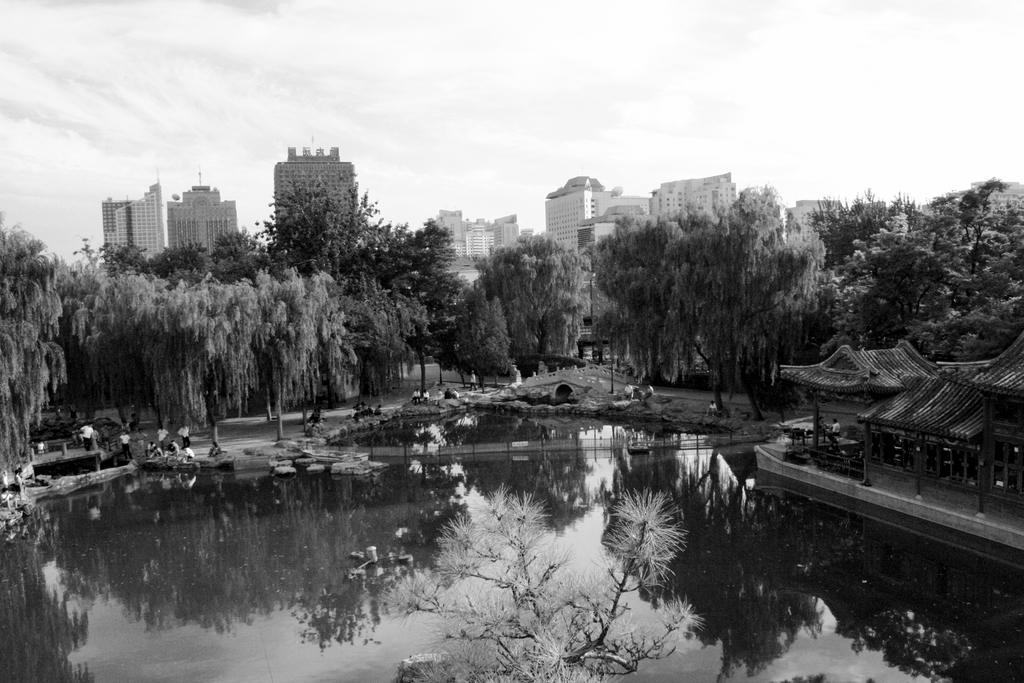Please provide a concise description of this image. In this picture we can see water and few people, in the background we can find few trees, buildings and clouds, it is a black and white photography. 